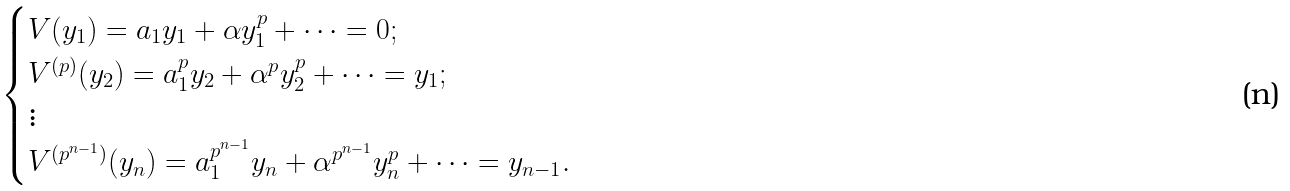<formula> <loc_0><loc_0><loc_500><loc_500>\begin{cases} V ( y _ { 1 } ) = a _ { 1 } y _ { 1 } + \alpha y _ { 1 } ^ { p } + \cdots = 0 ; \\ V ^ { ( p ) } ( y _ { 2 } ) = a _ { 1 } ^ { p } y _ { 2 } + \alpha ^ { p } y _ { 2 } ^ { p } + \cdots = y _ { 1 } ; \\ \vdots \\ V ^ { ( p ^ { n - 1 } ) } ( y _ { n } ) = a _ { 1 } ^ { p ^ { n - 1 } } y _ { n } + \alpha ^ { p ^ { n - 1 } } y _ { n } ^ { p } + \cdots = y _ { n - 1 } . \end{cases}</formula> 